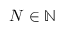<formula> <loc_0><loc_0><loc_500><loc_500>N \in \mathbb { N }</formula> 